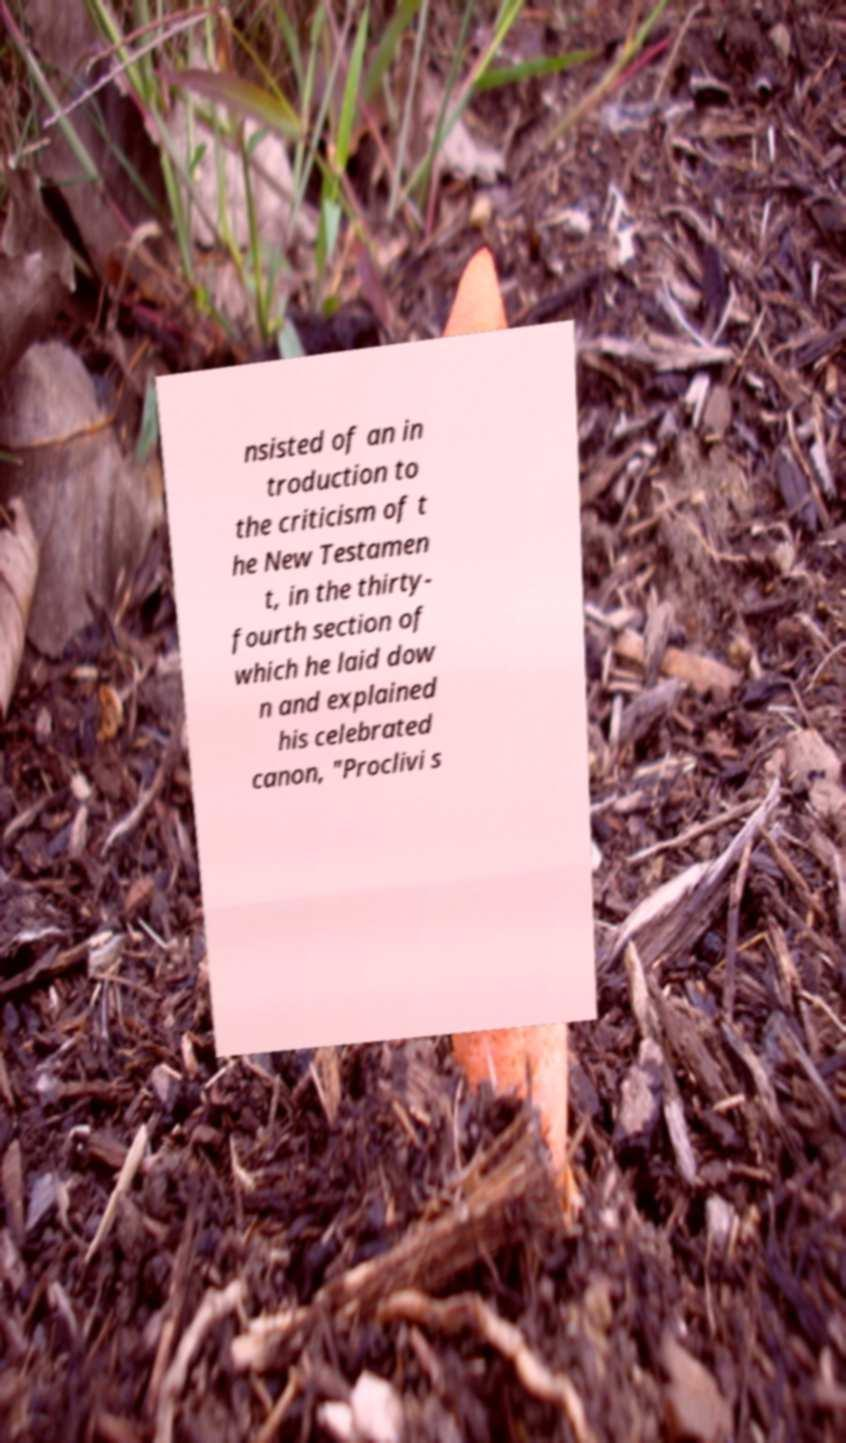I need the written content from this picture converted into text. Can you do that? nsisted of an in troduction to the criticism of t he New Testamen t, in the thirty- fourth section of which he laid dow n and explained his celebrated canon, "Proclivi s 